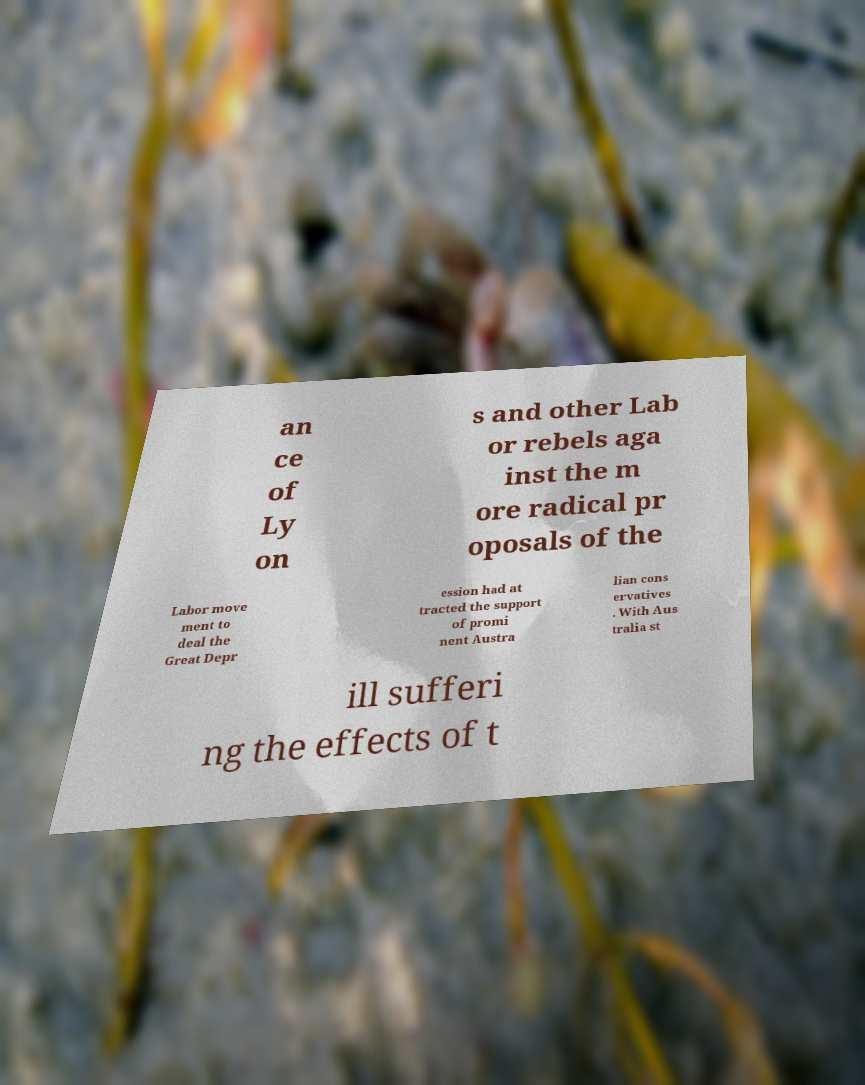Could you extract and type out the text from this image? an ce of Ly on s and other Lab or rebels aga inst the m ore radical pr oposals of the Labor move ment to deal the Great Depr ession had at tracted the support of promi nent Austra lian cons ervatives . With Aus tralia st ill sufferi ng the effects of t 